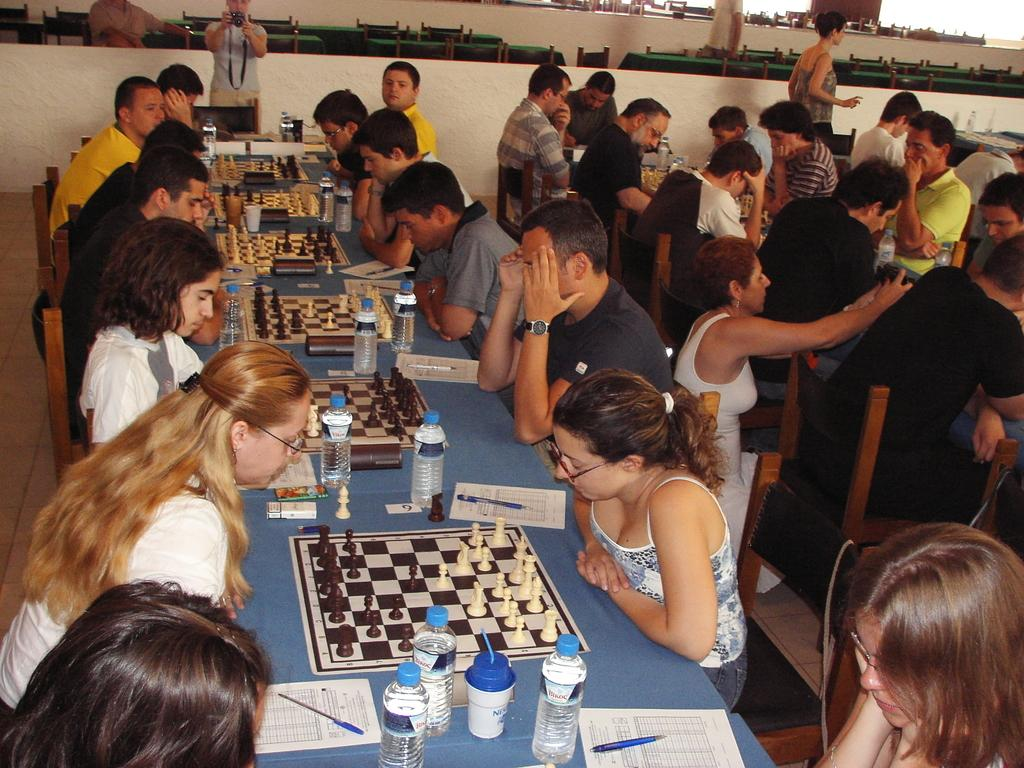What activity are the persons in the image engaged in? There is a group of persons playing chess in the image. Can you describe the position of the photographer in the image? The photographer is at the top of the image. What is the photographer doing? The photographer is taking photographs. What type of floor can be seen in the image? There is no specific mention of a floor in the image, as the focus is on the chess players and the photographer. Is there an attack happening in the image? There is no indication of an attack in the image; the focus is on the chess players and the photographer. 